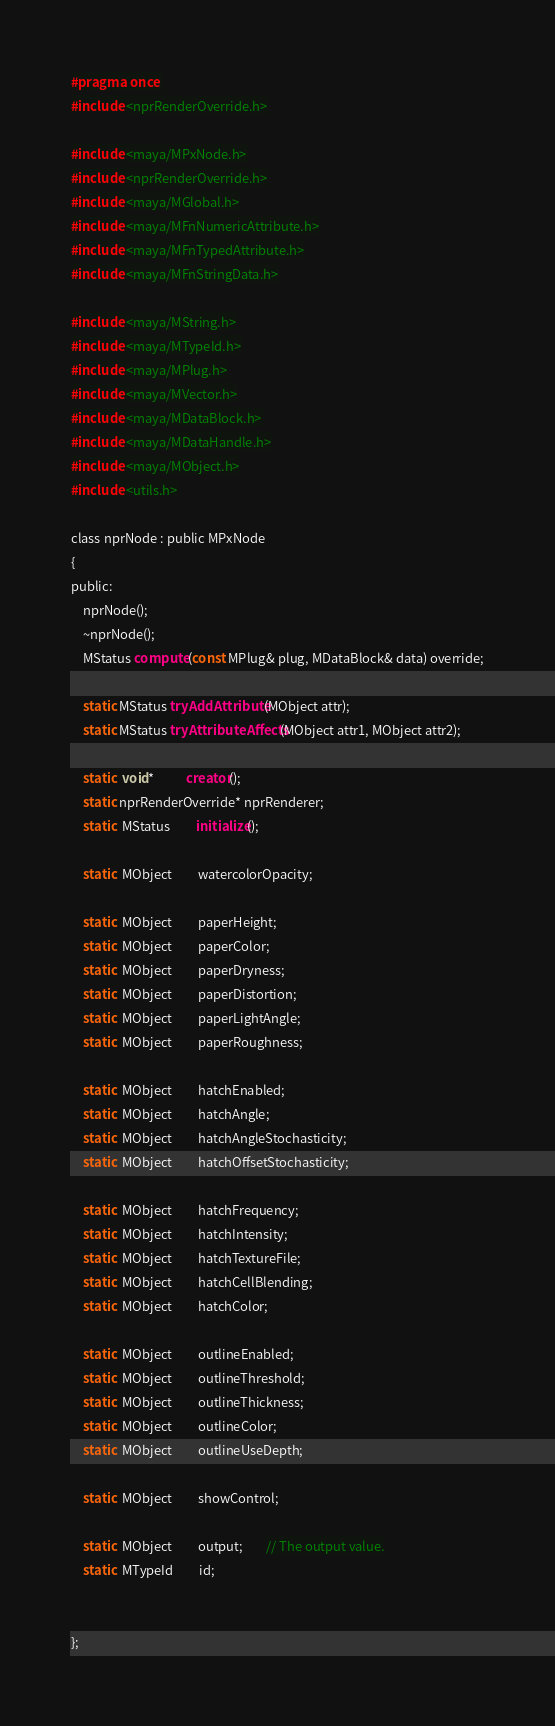<code> <loc_0><loc_0><loc_500><loc_500><_C_>#pragma once
#include <nprRenderOverride.h>

#include <maya/MPxNode.h>
#include <nprRenderOverride.h>
#include <maya/MGlobal.h>
#include <maya/MFnNumericAttribute.h>
#include <maya/MFnTypedAttribute.h>
#include <maya/MFnStringData.h>

#include <maya/MString.h>
#include <maya/MTypeId.h>
#include <maya/MPlug.h>
#include <maya/MVector.h>
#include <maya/MDataBlock.h>
#include <maya/MDataHandle.h>
#include <maya/MObject.h>
#include <utils.h>

class nprNode : public MPxNode
{
public:
    nprNode();
    ~nprNode();
    MStatus compute(const MPlug& plug, MDataBlock& data) override;

    static MStatus tryAddAttribute(MObject attr);
    static MStatus tryAttributeAffects(MObject attr1, MObject attr2);

    static  void*           creator();
    static nprRenderOverride* nprRenderer;
    static  MStatus         initialize();

    static  MObject         watercolorOpacity;

    static  MObject         paperHeight;
    static  MObject         paperColor;
    static  MObject         paperDryness;
    static  MObject         paperDistortion;
    static  MObject         paperLightAngle;
    static  MObject         paperRoughness;

    static  MObject         hatchEnabled;
    static  MObject         hatchAngle;
    static  MObject         hatchAngleStochasticity;
    static  MObject         hatchOffsetStochasticity;

    static  MObject         hatchFrequency;
    static  MObject         hatchIntensity;
    static  MObject         hatchTextureFile;
    static  MObject         hatchCellBlending;
    static  MObject         hatchColor;

    static  MObject         outlineEnabled;
    static  MObject         outlineThreshold;
    static  MObject         outlineThickness;
    static  MObject         outlineColor;
    static  MObject         outlineUseDepth;

    static  MObject         showControl;

    static  MObject         output;        // The output value.
    static  MTypeId         id;


};


</code> 